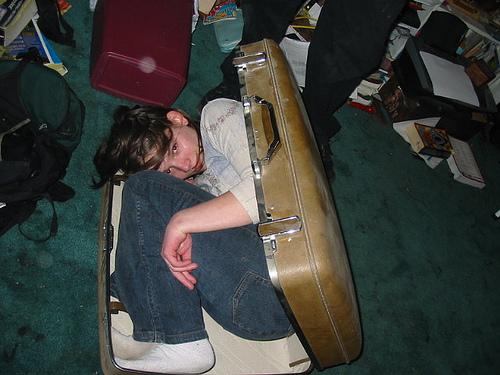Is the girl barefoot?
Be succinct. No. What is the girl inside of?
Be succinct. Suitcase. Will the girl eat bean burritos before closing the suitcase?
Short answer required. No. 